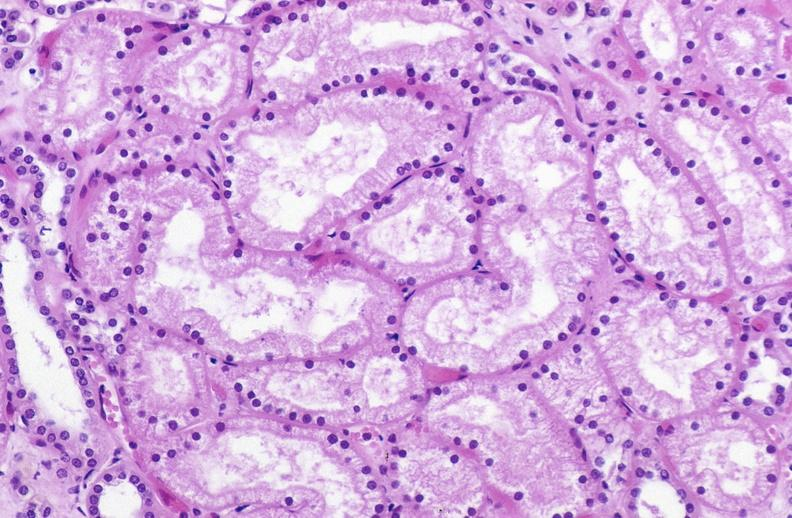s digital infarcts bacterial endocarditis present?
Answer the question using a single word or phrase. No 